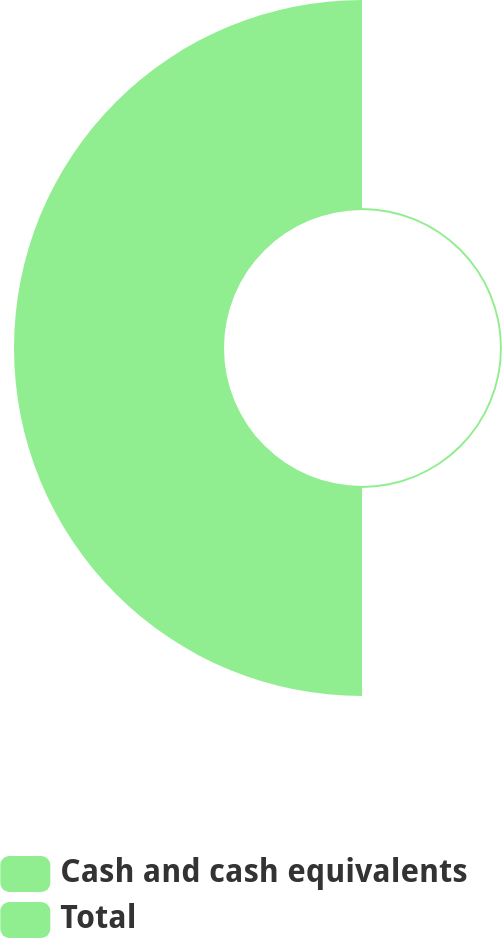Convert chart to OTSL. <chart><loc_0><loc_0><loc_500><loc_500><pie_chart><fcel>Cash and cash equivalents<fcel>Total<nl><fcel>0.9%<fcel>99.1%<nl></chart> 